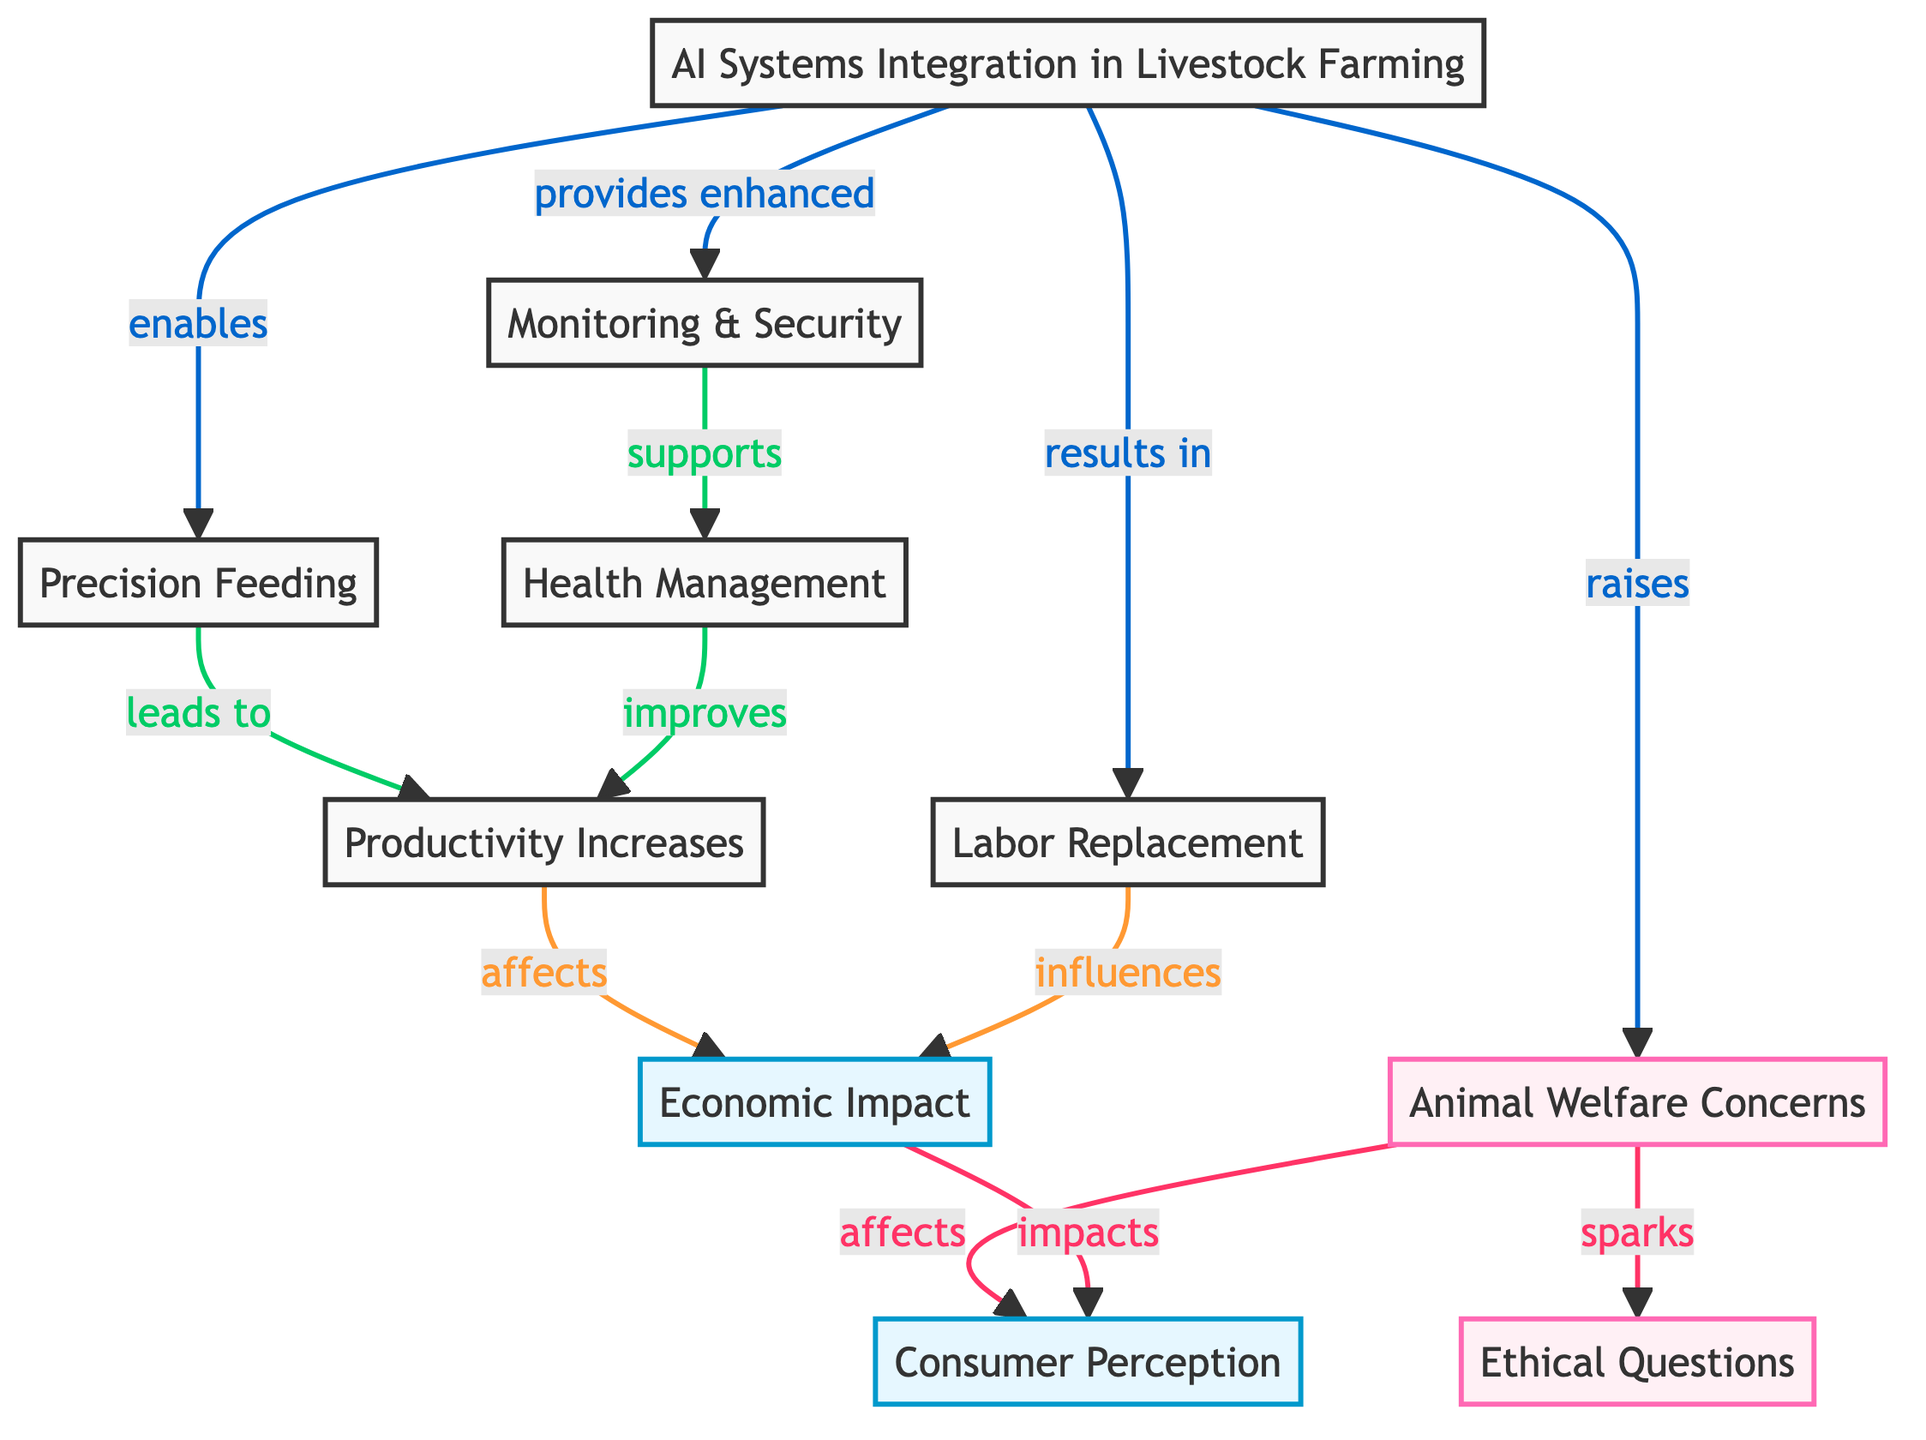What is the first node in the diagram? The first node in the diagram is labeled "AI Systems Integration in Livestock Farming," which is depicted as the initial point of the flowchart.
Answer: AI Systems Integration in Livestock Farming How many nodes are there in total? The diagram includes a total of 11 nodes, representing different aspects related to AI integration in livestock farming.
Answer: 11 Which node is directly influenced by "Monitoring & Security"? The node that is directly influenced by "Monitoring & Security" is "Health Management," indicating that monitoring supports the health management processes.
Answer: Health Management What does "Precision Feeding" lead to? "Precision Feeding" leads to "Productivity Increases," showing the direct relationship between targeted feeding and enhanced productivity outcomes.
Answer: Productivity Increases What is the relationship between "Animal Welfare Concerns" and "Ethical Questions"? The relationship between "Animal Welfare Concerns" and "Ethical Questions" is that animal welfare concerns spark ethical questions, highlighting the moral dilemmas arising from livestock farming practices.
Answer: Spark How does "Labor Replacement" affect the "Economic Impact"? "Labor Replacement" influences "Economic Impact" by potentially reducing costs and changing labor dynamics; this indicates the economic consequences of AI applications in farming.
Answer: Influences What two nodes are directly affected by "Animal Welfare Concerns"? "Animal Welfare Concerns" directly affects "Ethical Questions" and "Consumer Perception," demonstrating the social implications of animal treatment in farming practices.
Answer: Ethical Questions and Consumer Perception Which node first leads to the "Economic Impact"? The nodes that lead to "Economic Impact" are "Productivity Increases" and "Labor Replacement," indicating they both have a direct effect on the economic outcomes.
Answer: Productivity Increases and Labor Replacement What type of question is raised by concerns for animal welfare? The type of question raised by concerns for animal welfare is "Ethical Questions," reflecting the moral considerations surrounding animal rights in farming operations.
Answer: Ethical Questions 